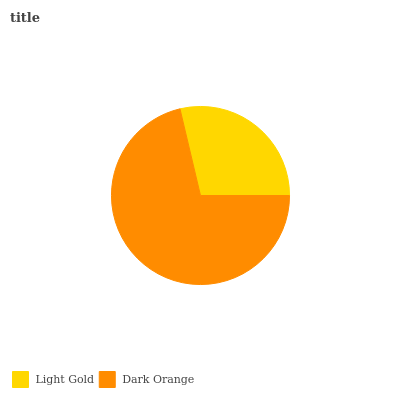Is Light Gold the minimum?
Answer yes or no. Yes. Is Dark Orange the maximum?
Answer yes or no. Yes. Is Dark Orange the minimum?
Answer yes or no. No. Is Dark Orange greater than Light Gold?
Answer yes or no. Yes. Is Light Gold less than Dark Orange?
Answer yes or no. Yes. Is Light Gold greater than Dark Orange?
Answer yes or no. No. Is Dark Orange less than Light Gold?
Answer yes or no. No. Is Dark Orange the high median?
Answer yes or no. Yes. Is Light Gold the low median?
Answer yes or no. Yes. Is Light Gold the high median?
Answer yes or no. No. Is Dark Orange the low median?
Answer yes or no. No. 